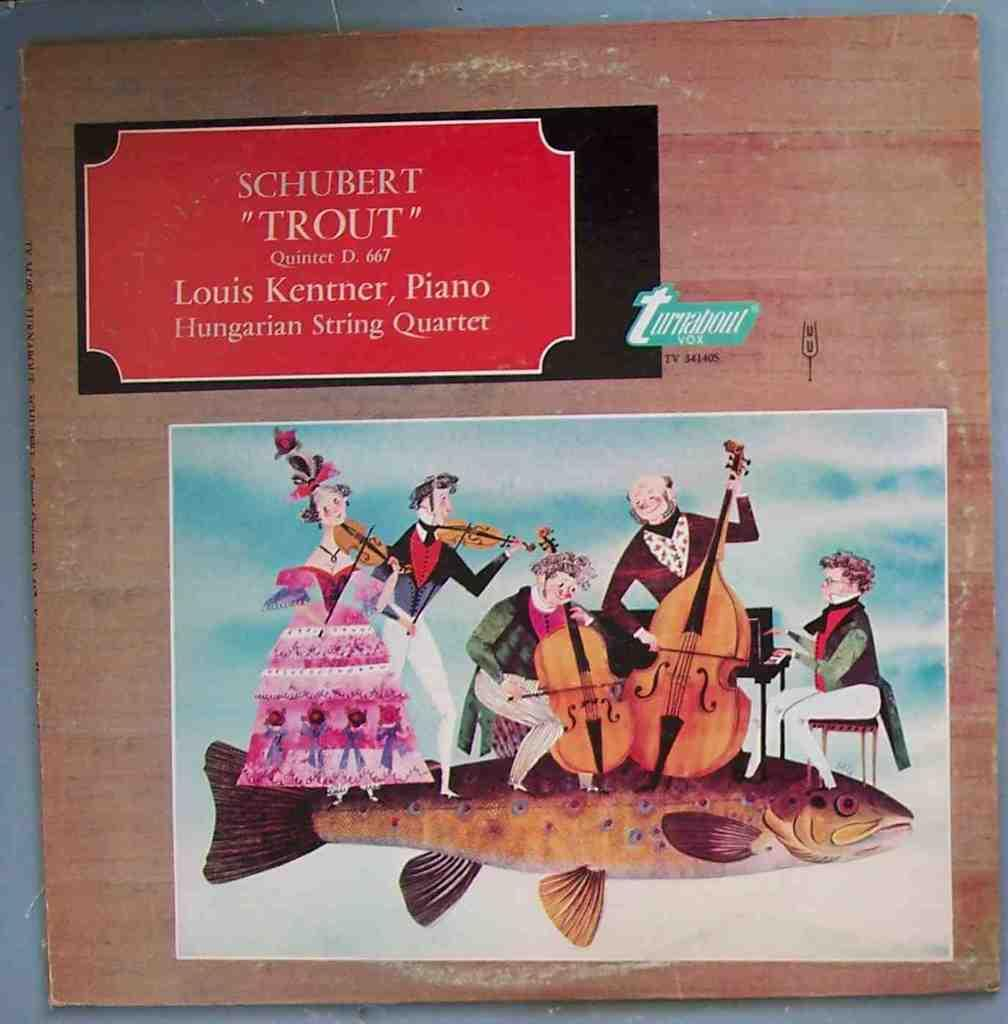<image>
Describe the image concisely. a painting of men and women playing in an orchestra that is titled trout. 